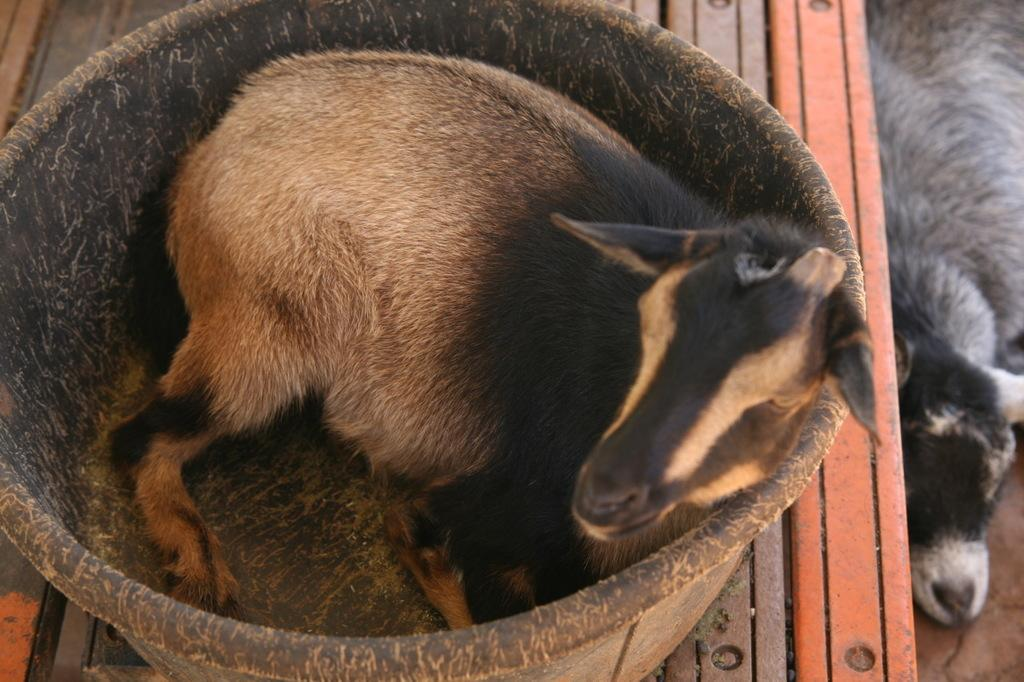What animal is sitting on the table in the image? There is a goat sitting on a table in the image. Can you describe the position of the other goat in the image? There is another goat on the floor in the image. What type of surface is visible in the image? There is a surface in the image, which could be a table or the floor. What type of coat is the goat wearing in the image? The goat is not wearing a coat in the image; it is a goat, and they do not typically wear coats. 